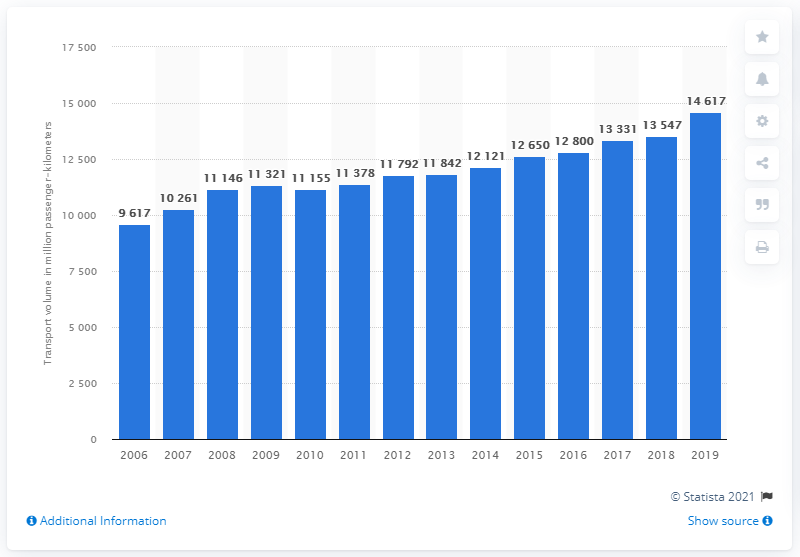Highlight a few significant elements in this photo. In 2019, passenger rail transport reached its peak with a total of 14,617 passenger-kilometers. 